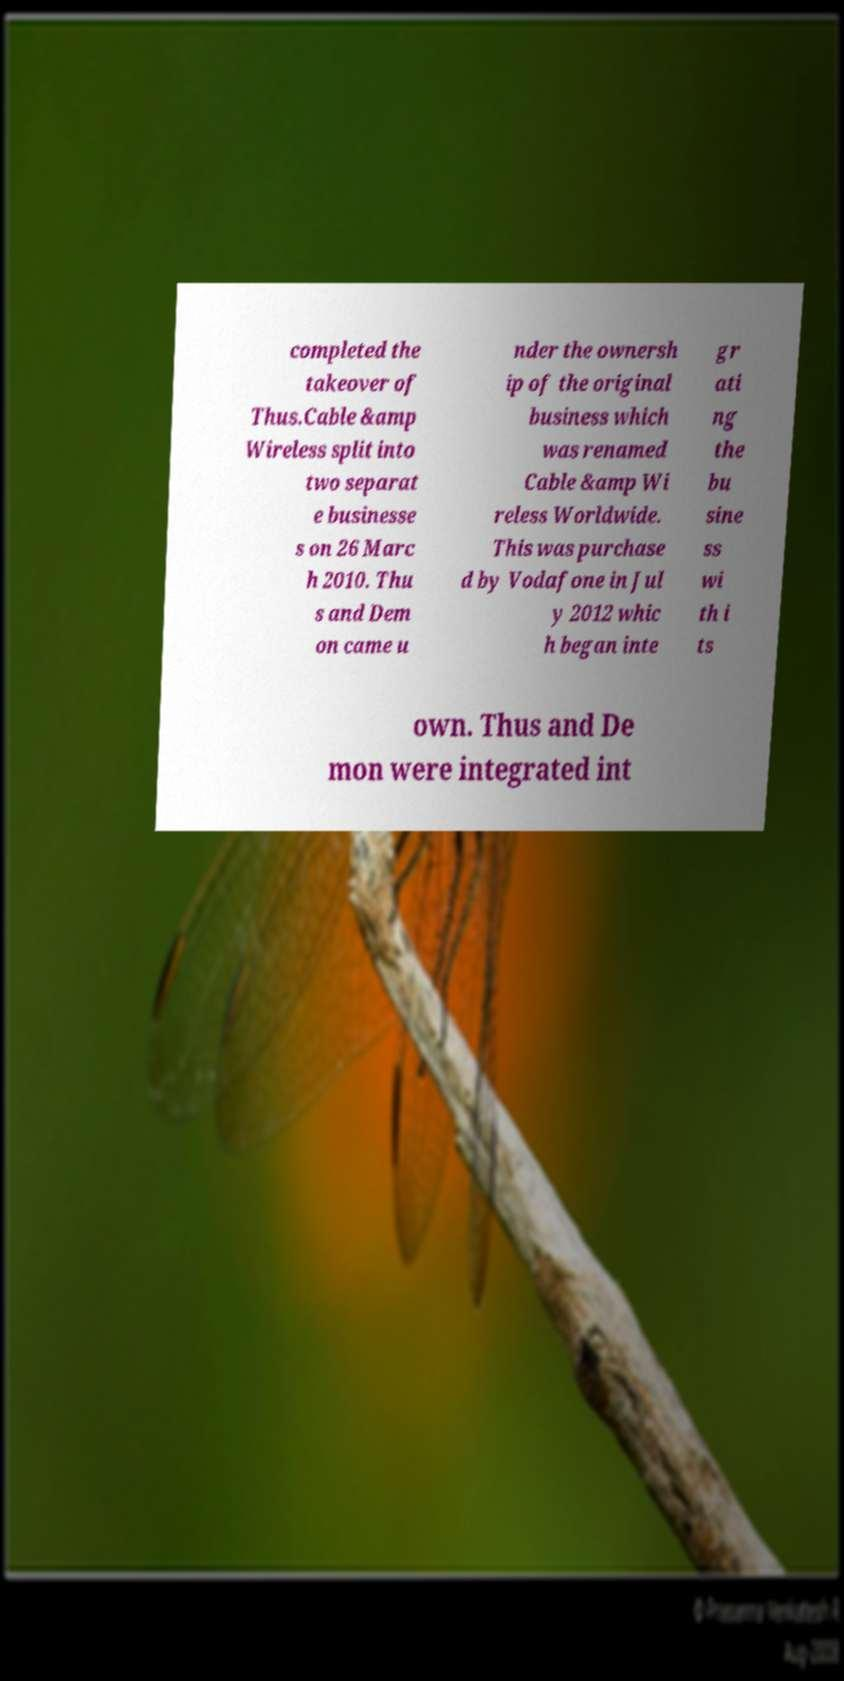Can you read and provide the text displayed in the image?This photo seems to have some interesting text. Can you extract and type it out for me? completed the takeover of Thus.Cable &amp Wireless split into two separat e businesse s on 26 Marc h 2010. Thu s and Dem on came u nder the ownersh ip of the original business which was renamed Cable &amp Wi reless Worldwide. This was purchase d by Vodafone in Jul y 2012 whic h began inte gr ati ng the bu sine ss wi th i ts own. Thus and De mon were integrated int 